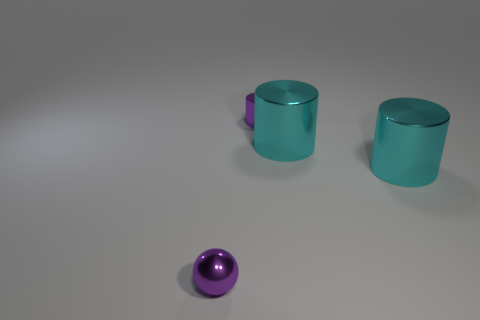Add 1 cyan shiny cylinders. How many objects exist? 5 Subtract all cylinders. How many objects are left? 1 Add 4 spheres. How many spheres exist? 5 Subtract 0 yellow cylinders. How many objects are left? 4 Subtract all big yellow balls. Subtract all cyan metal things. How many objects are left? 2 Add 2 large metallic things. How many large metallic things are left? 4 